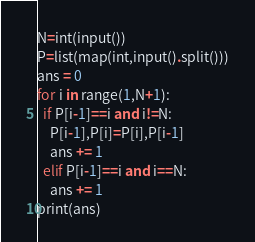Convert code to text. <code><loc_0><loc_0><loc_500><loc_500><_Python_>N=int(input())
P=list(map(int,input().split()))
ans = 0
for i in range(1,N+1):
  if P[i-1]==i and i!=N:
    P[i-1],P[i]=P[i],P[i-1]
    ans += 1
  elif P[i-1]==i and i==N:
    ans += 1
print(ans)</code> 